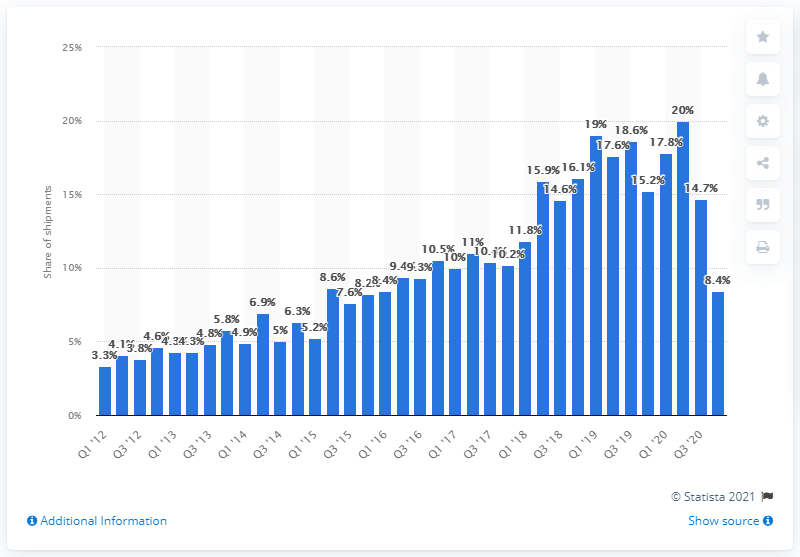Indicate a few pertinent items in this graphic. Huawei held an 8.4% market share of the global smartphone market in the fourth quarter of 2020. 